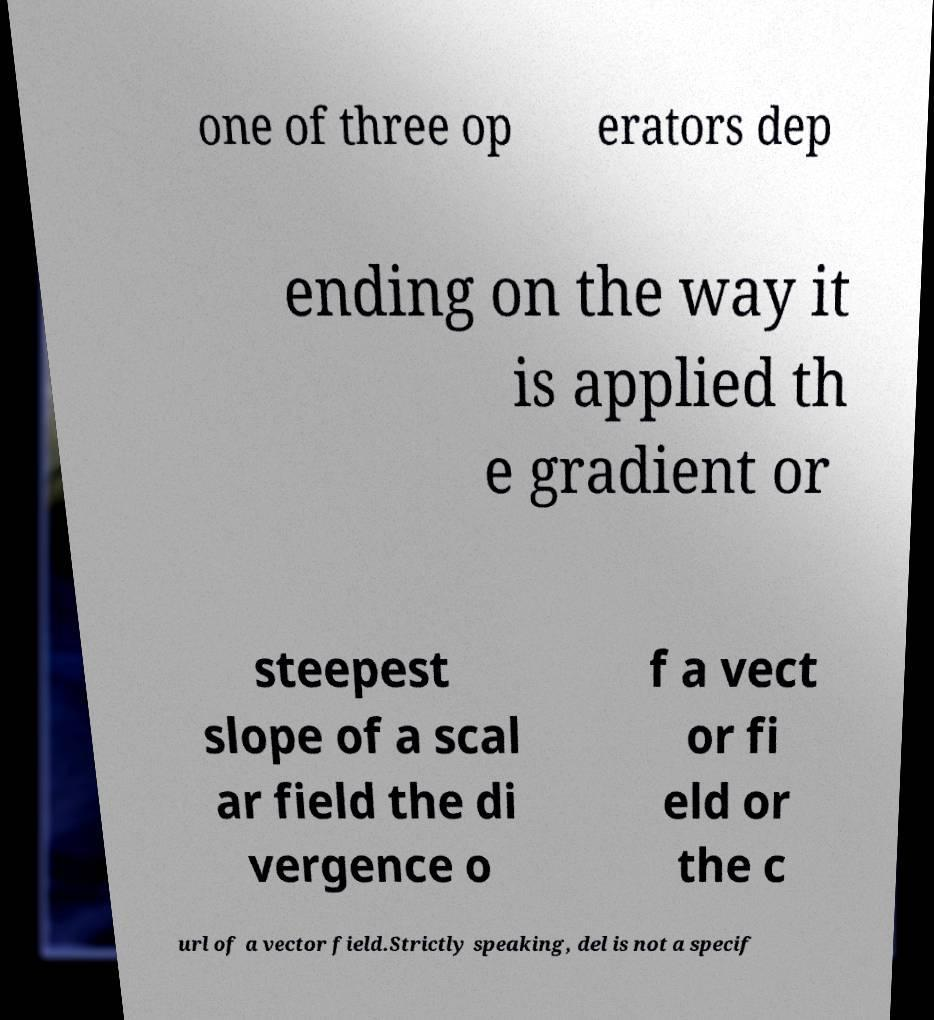Could you extract and type out the text from this image? one of three op erators dep ending on the way it is applied th e gradient or steepest slope of a scal ar field the di vergence o f a vect or fi eld or the c url of a vector field.Strictly speaking, del is not a specif 